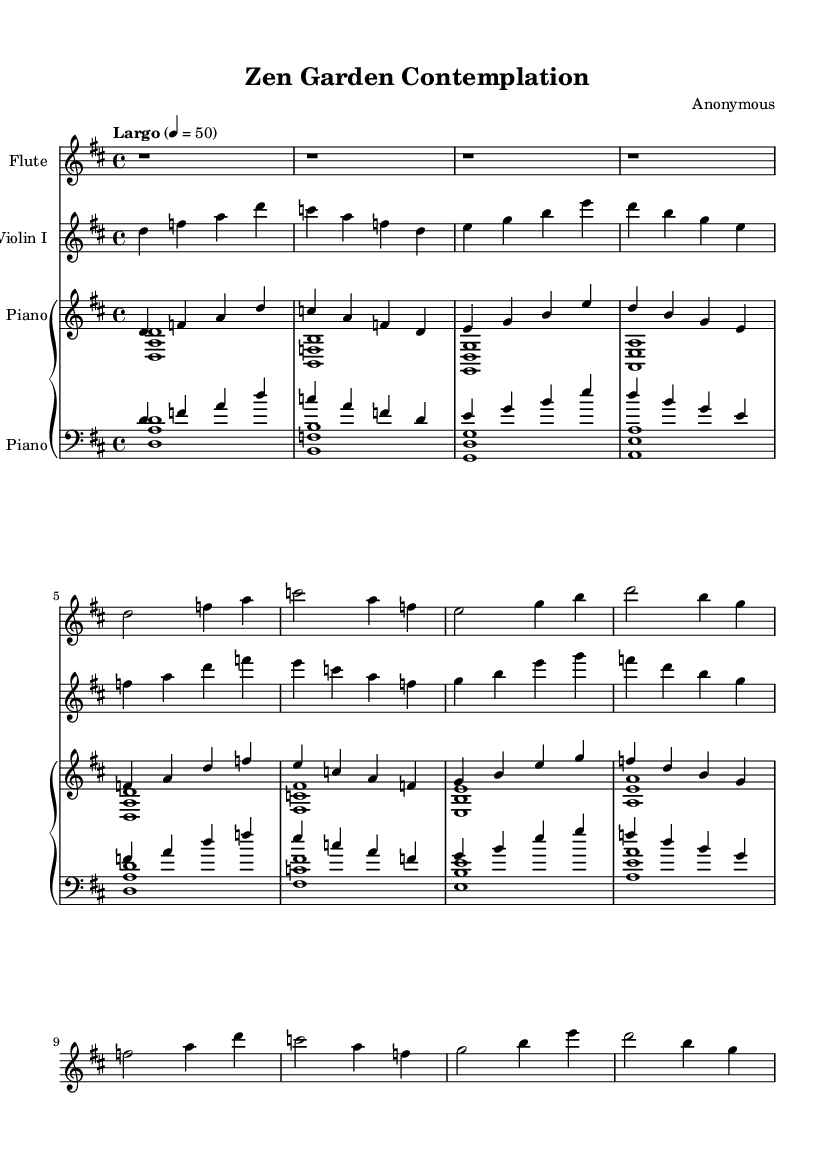What is the key signature of this music? The key signature is D major, which has two sharps (F# and C#). You can determine this by examining the key signature indicated at the beginning of the staff, which shows two sharps.
Answer: D major What is the time signature of this piece? The time signature is 4/4, indicating four beats in a measure and a quarter note gets one beat. This can be deduced from the time signature shown at the beginning of the score, which is positioned next to the clef sign.
Answer: 4/4 What is the tempo marking in this score? The tempo marking is "Largo," indicating a slow tempo. This is indicated above the staff in the score and conveys the general speed at which the piece should be performed.
Answer: Largo Which instruments are included in this composition? The instruments included are Flute, Violin I, and Piano. The names of the instruments appear at the beginning of each staff, identifying what is to be performed on that staff.
Answer: Flute, Violin I, and Piano How many measures are in the flute part? There are eight measures in the flute part. Counting each separated section with a vertical bar shows a total of eight measures in this section of the score.
Answer: 8 What is the highest note in the piano staff? The highest note in the piano staff is D in the right hand at the start of the score. You can identify the highest note by looking at the notes presented in the upper staff of the piano, particularly at the beginning of the piece.
Answer: D How many flats are in the key signature? There are zero flats in the key signature. By examining the key signature indicated at the beginning of the score, we can see that it has two sharps, indicating the absence of flats.
Answer: 0 